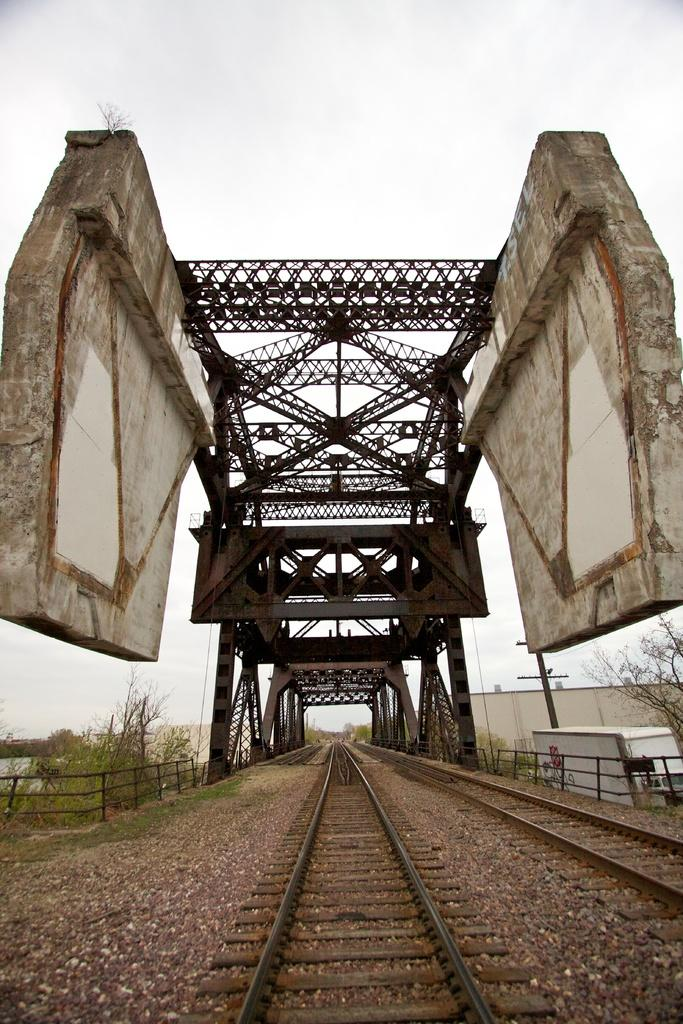What type of transportation infrastructure is visible in the image? There are railway tracks in the image. What structure is present over the railway tracks? There is a bridge in the image. What type of natural environment is visible in the image? There are trees in the image. What type of man-made structure is visible in the image? There is a building in the image. How would you describe the weather in the image? The sky is cloudy in the image. What type of alarm system is installed in the building in the image? There is no information about an alarm system in the building in the image. What type of wealth is visible in the image? There is no indication of wealth in the image; it features railway tracks, a bridge, trees, a building, and a cloudy sky. 